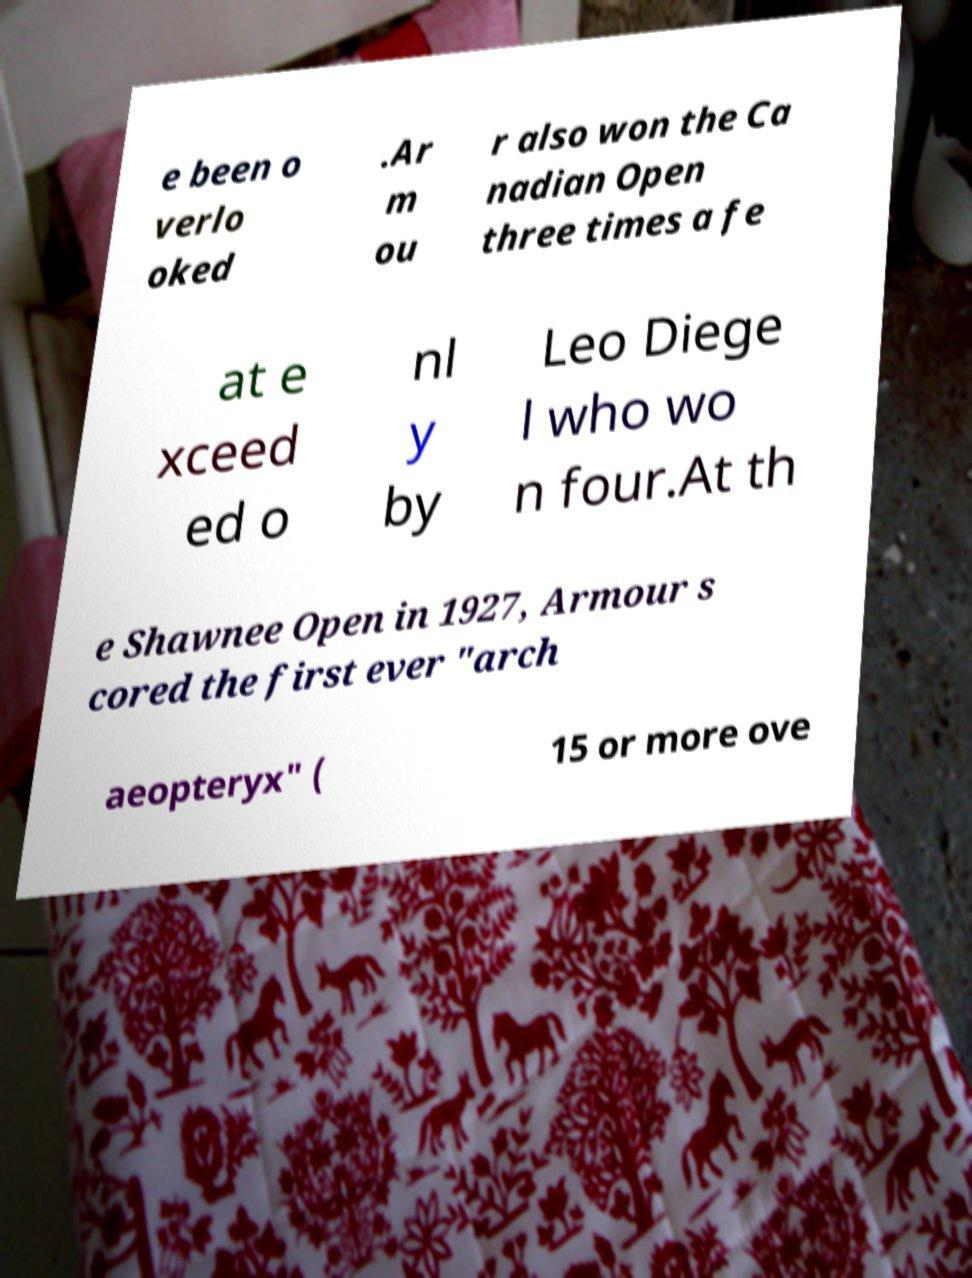Can you read and provide the text displayed in the image?This photo seems to have some interesting text. Can you extract and type it out for me? e been o verlo oked .Ar m ou r also won the Ca nadian Open three times a fe at e xceed ed o nl y by Leo Diege l who wo n four.At th e Shawnee Open in 1927, Armour s cored the first ever "arch aeopteryx" ( 15 or more ove 